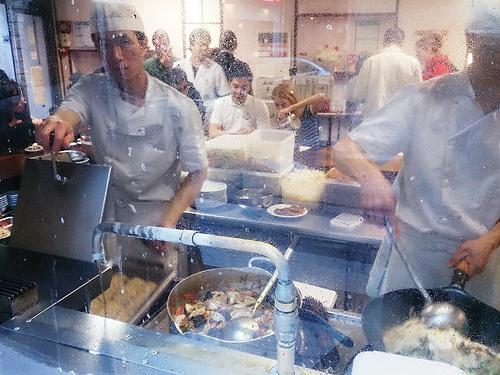Question: what type of restaurant might this be?
Choices:
A. Chinese.
B. Italian.
C. French.
D. Thai.
Answer with the letter. Answer: A Question: how many cooks are there?
Choices:
A. 1.
B. 2.
C. 3.
D. 4.
Answer with the letter. Answer: B Question: where is the wok?
Choices:
A. In the sink.
B. On the counter.
C. On the stove.
D. In the cabinet.
Answer with the letter. Answer: C Question: who is in the background?
Choices:
A. Children.
B. Doctors and nurses.
C. Janitors.
D. Customers.
Answer with the letter. Answer: D Question: why are the people here?
Choices:
A. To celebrate.
B. To go swimming.
C. To get food.
D. To listen to music.
Answer with the letter. Answer: C Question: when was this photo taken?
Choices:
A. At night.
B. Early morning.
C. Holloween.
D. During the day.
Answer with the letter. Answer: D 